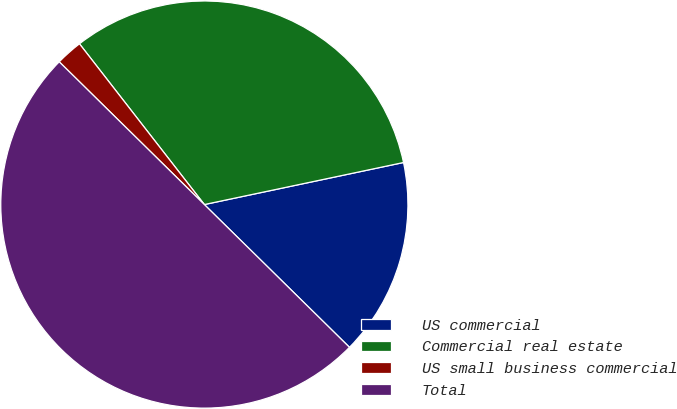Convert chart to OTSL. <chart><loc_0><loc_0><loc_500><loc_500><pie_chart><fcel>US commercial<fcel>Commercial real estate<fcel>US small business commercial<fcel>Total<nl><fcel>15.68%<fcel>32.2%<fcel>2.12%<fcel>50.0%<nl></chart> 